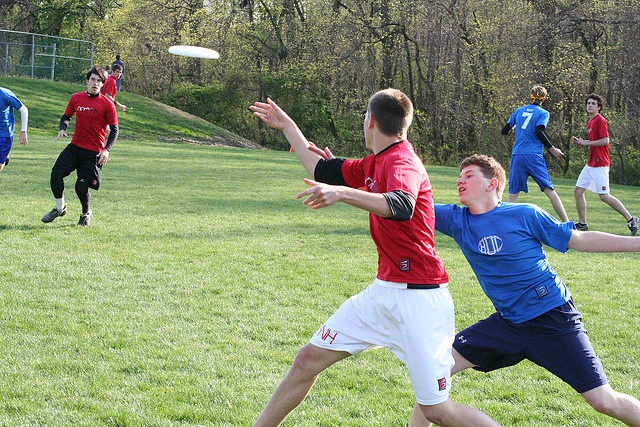Describe the objects in this image and their specific colors. I can see people in black, lavender, brown, and darkgray tones, people in black, blue, and navy tones, people in black, brown, maroon, and darkgray tones, people in black, blue, and darkblue tones, and people in black, gray, darkgray, lavender, and brown tones in this image. 